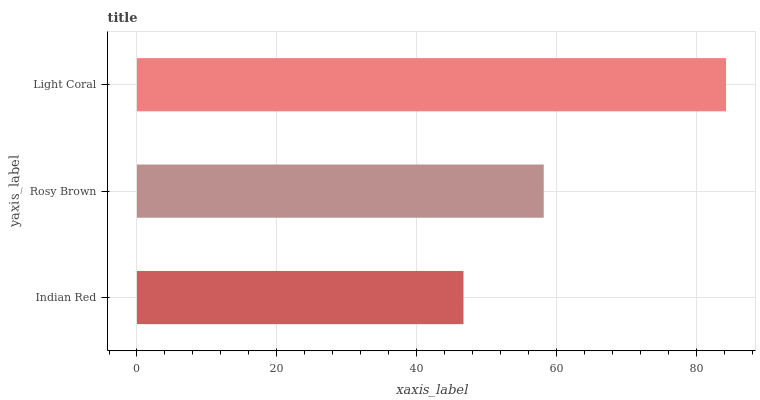Is Indian Red the minimum?
Answer yes or no. Yes. Is Light Coral the maximum?
Answer yes or no. Yes. Is Rosy Brown the minimum?
Answer yes or no. No. Is Rosy Brown the maximum?
Answer yes or no. No. Is Rosy Brown greater than Indian Red?
Answer yes or no. Yes. Is Indian Red less than Rosy Brown?
Answer yes or no. Yes. Is Indian Red greater than Rosy Brown?
Answer yes or no. No. Is Rosy Brown less than Indian Red?
Answer yes or no. No. Is Rosy Brown the high median?
Answer yes or no. Yes. Is Rosy Brown the low median?
Answer yes or no. Yes. Is Light Coral the high median?
Answer yes or no. No. Is Light Coral the low median?
Answer yes or no. No. 